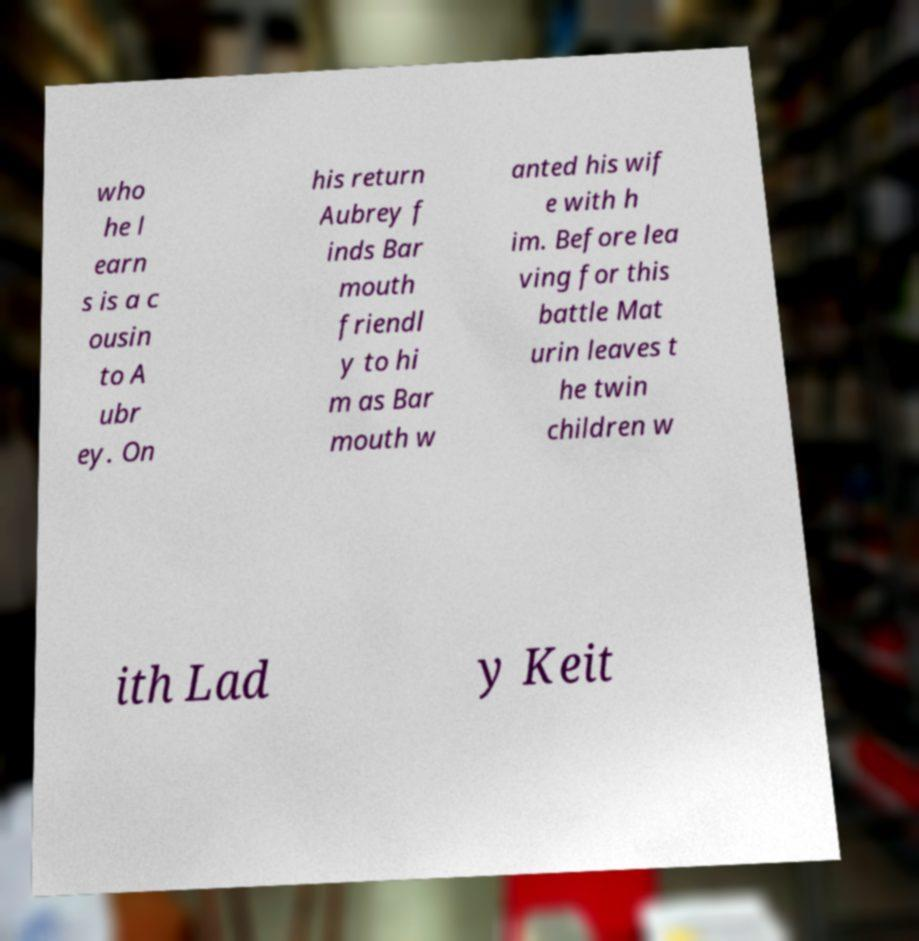I need the written content from this picture converted into text. Can you do that? who he l earn s is a c ousin to A ubr ey. On his return Aubrey f inds Bar mouth friendl y to hi m as Bar mouth w anted his wif e with h im. Before lea ving for this battle Mat urin leaves t he twin children w ith Lad y Keit 